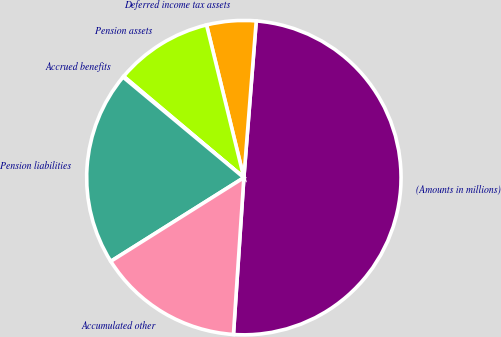Convert chart to OTSL. <chart><loc_0><loc_0><loc_500><loc_500><pie_chart><fcel>(Amounts in millions)<fcel>Deferred income tax assets<fcel>Pension assets<fcel>Accrued benefits<fcel>Pension liabilities<fcel>Accumulated other<nl><fcel>49.8%<fcel>5.07%<fcel>10.04%<fcel>0.1%<fcel>19.98%<fcel>15.01%<nl></chart> 